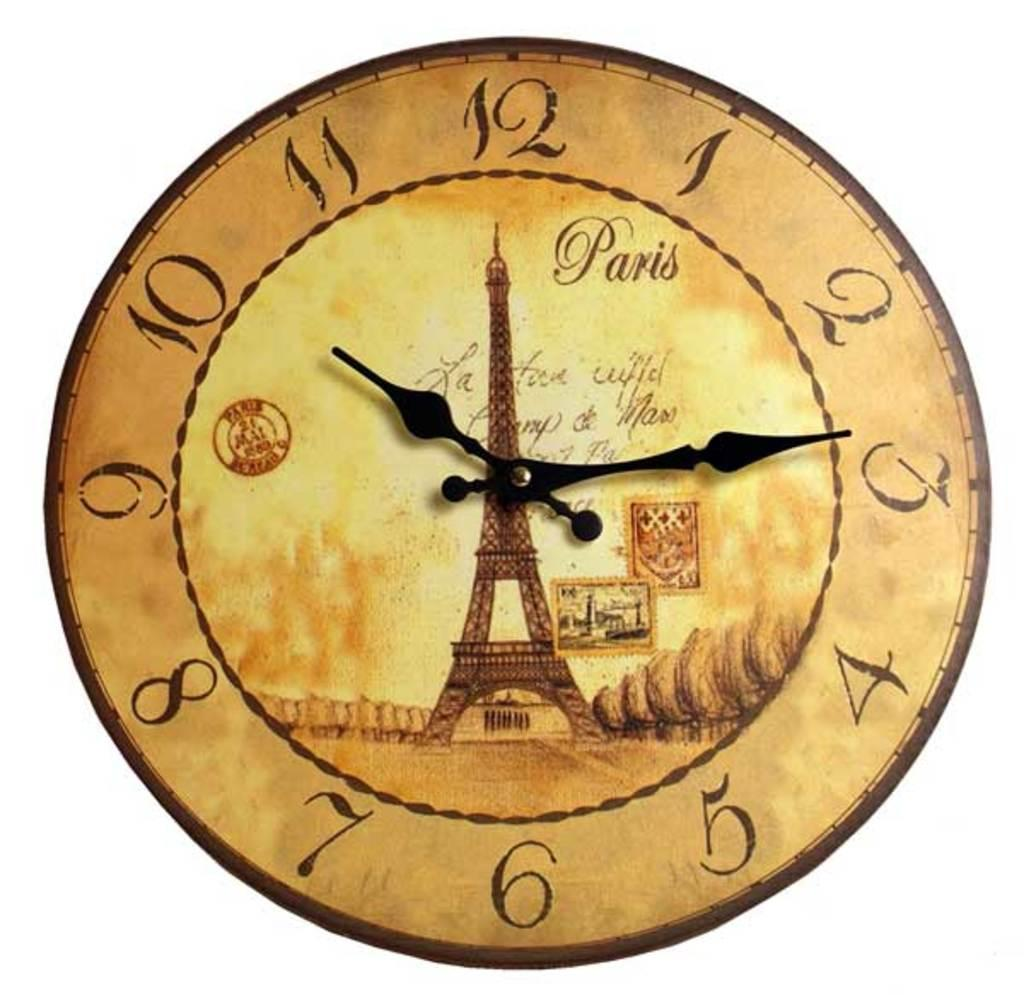Provide a one-sentence caption for the provided image. the name Paris is on the front of a clock. 